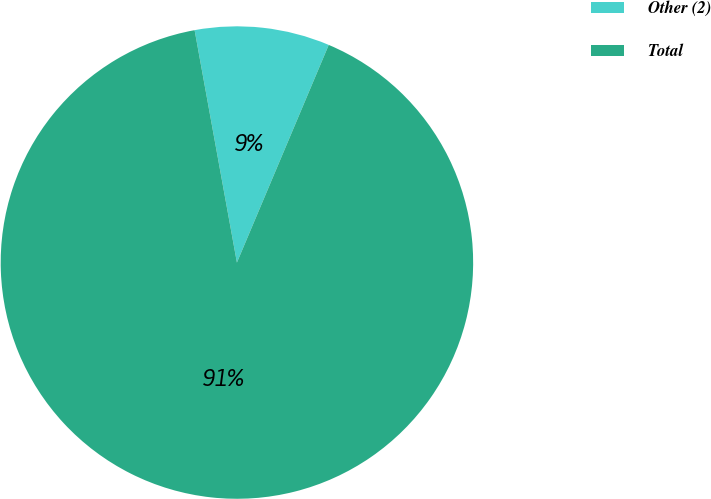Convert chart to OTSL. <chart><loc_0><loc_0><loc_500><loc_500><pie_chart><fcel>Other (2)<fcel>Total<nl><fcel>9.22%<fcel>90.78%<nl></chart> 